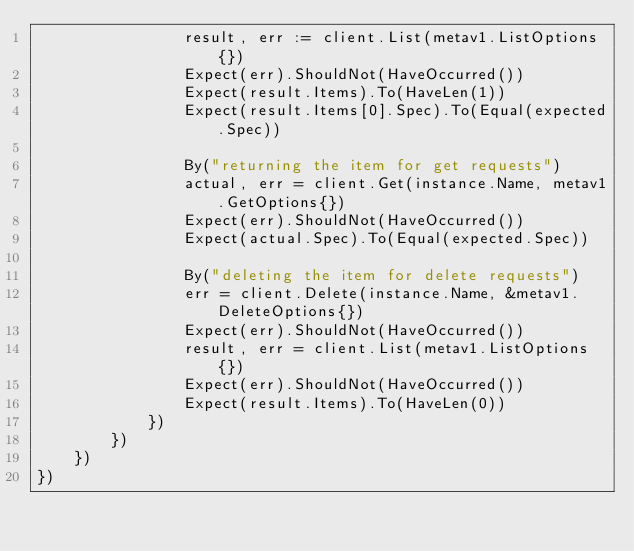<code> <loc_0><loc_0><loc_500><loc_500><_Go_>				result, err := client.List(metav1.ListOptions{})
				Expect(err).ShouldNot(HaveOccurred())
				Expect(result.Items).To(HaveLen(1))
				Expect(result.Items[0].Spec).To(Equal(expected.Spec))

				By("returning the item for get requests")
				actual, err = client.Get(instance.Name, metav1.GetOptions{})
				Expect(err).ShouldNot(HaveOccurred())
				Expect(actual.Spec).To(Equal(expected.Spec))

				By("deleting the item for delete requests")
				err = client.Delete(instance.Name, &metav1.DeleteOptions{})
				Expect(err).ShouldNot(HaveOccurred())
				result, err = client.List(metav1.ListOptions{})
				Expect(err).ShouldNot(HaveOccurred())
				Expect(result.Items).To(HaveLen(0))
			})
		})
	})
})
</code> 